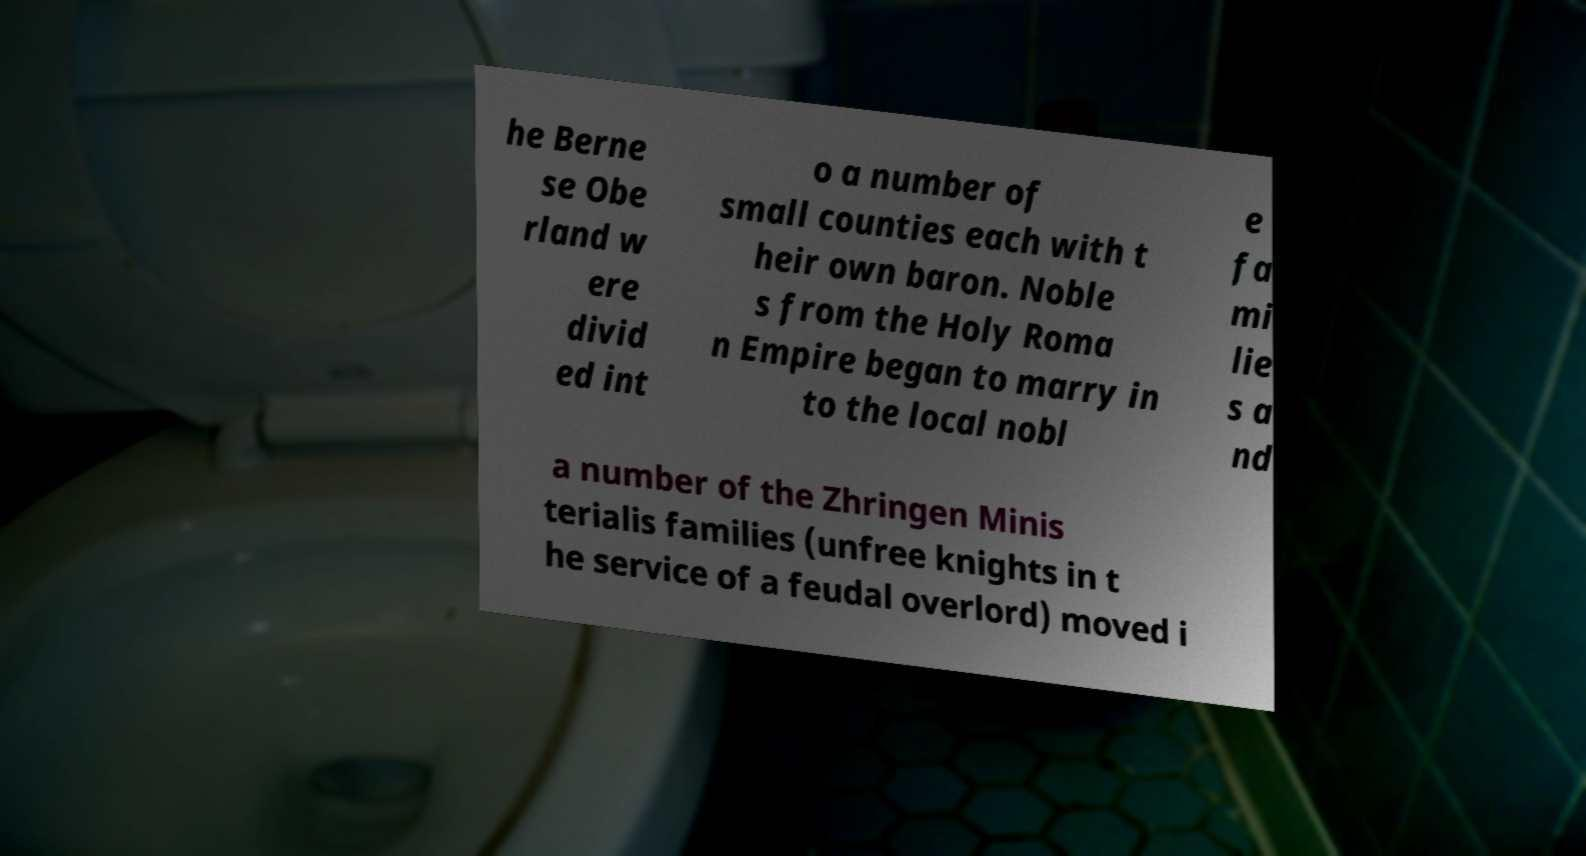Could you assist in decoding the text presented in this image and type it out clearly? he Berne se Obe rland w ere divid ed int o a number of small counties each with t heir own baron. Noble s from the Holy Roma n Empire began to marry in to the local nobl e fa mi lie s a nd a number of the Zhringen Minis terialis families (unfree knights in t he service of a feudal overlord) moved i 